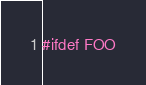<code> <loc_0><loc_0><loc_500><loc_500><_C_>#ifdef FOO
</code> 